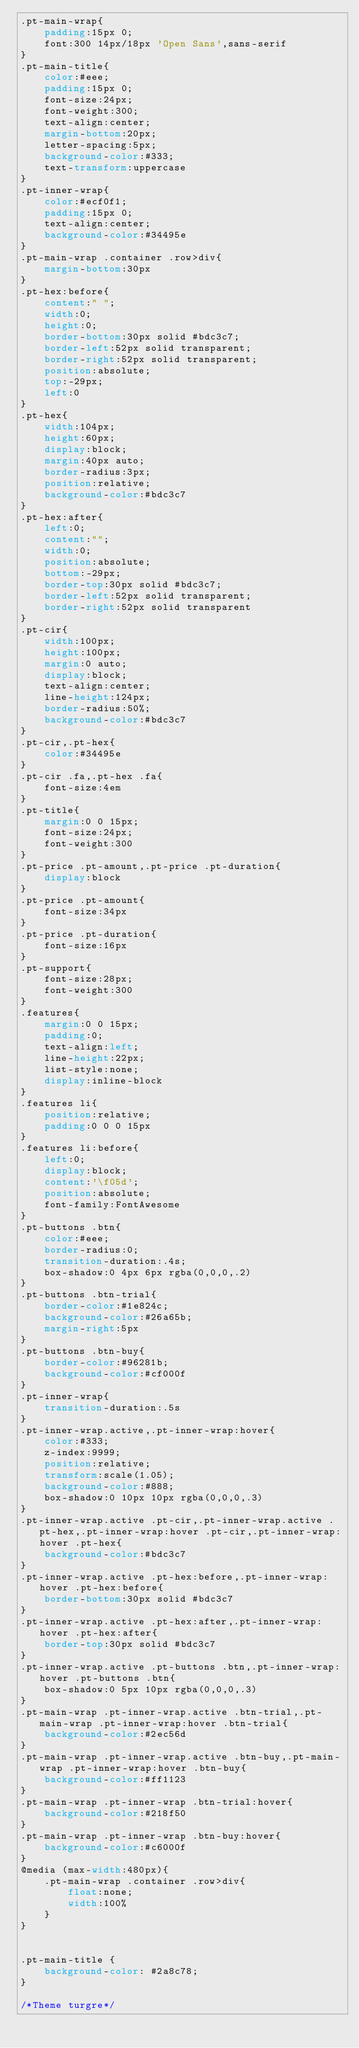<code> <loc_0><loc_0><loc_500><loc_500><_CSS_>.pt-main-wrap{
    padding:15px 0;
    font:300 14px/18px 'Open Sans',sans-serif
}
.pt-main-title{
    color:#eee;
    padding:15px 0;
    font-size:24px;
    font-weight:300;
    text-align:center;
    margin-bottom:20px;
    letter-spacing:5px;
    background-color:#333;
    text-transform:uppercase
}
.pt-inner-wrap{
    color:#ecf0f1;
    padding:15px 0;
    text-align:center;
    background-color:#34495e
}
.pt-main-wrap .container .row>div{
    margin-bottom:30px
}
.pt-hex:before{
    content:" ";
    width:0;
    height:0;
    border-bottom:30px solid #bdc3c7;
    border-left:52px solid transparent;
    border-right:52px solid transparent;
    position:absolute;
    top:-29px;
    left:0
}
.pt-hex{
    width:104px;
    height:60px;
    display:block;
    margin:40px auto;
    border-radius:3px;
    position:relative;
    background-color:#bdc3c7
}
.pt-hex:after{
    left:0;
    content:"";
    width:0;
    position:absolute;
    bottom:-29px;
    border-top:30px solid #bdc3c7;
    border-left:52px solid transparent;
    border-right:52px solid transparent
}
.pt-cir{
    width:100px;
    height:100px;
    margin:0 auto;
    display:block;
    text-align:center;
    line-height:124px;
    border-radius:50%;
    background-color:#bdc3c7
}
.pt-cir,.pt-hex{
    color:#34495e
}
.pt-cir .fa,.pt-hex .fa{
    font-size:4em
}
.pt-title{
    margin:0 0 15px;
    font-size:24px;
    font-weight:300
}
.pt-price .pt-amount,.pt-price .pt-duration{
    display:block
}
.pt-price .pt-amount{
    font-size:34px
}
.pt-price .pt-duration{
    font-size:16px
}
.pt-support{
    font-size:28px;
    font-weight:300
}
.features{
    margin:0 0 15px;
    padding:0;
    text-align:left;
    line-height:22px;
    list-style:none;
    display:inline-block
}
.features li{
    position:relative;
    padding:0 0 0 15px
}
.features li:before{
    left:0;
    display:block;
    content:'\f05d';
    position:absolute;
    font-family:FontAwesome
}
.pt-buttons .btn{
    color:#eee;
    border-radius:0;
    transition-duration:.4s;
    box-shadow:0 4px 6px rgba(0,0,0,.2)
}
.pt-buttons .btn-trial{
    border-color:#1e824c;
    background-color:#26a65b;
    margin-right:5px
}
.pt-buttons .btn-buy{
    border-color:#96281b;
    background-color:#cf000f
}
.pt-inner-wrap{
    transition-duration:.5s
}
.pt-inner-wrap.active,.pt-inner-wrap:hover{
    color:#333;
    z-index:9999;
    position:relative;
    transform:scale(1.05);
    background-color:#888;
    box-shadow:0 10px 10px rgba(0,0,0,.3)
}
.pt-inner-wrap.active .pt-cir,.pt-inner-wrap.active .pt-hex,.pt-inner-wrap:hover .pt-cir,.pt-inner-wrap:hover .pt-hex{
    background-color:#bdc3c7
}
.pt-inner-wrap.active .pt-hex:before,.pt-inner-wrap:hover .pt-hex:before{
    border-bottom:30px solid #bdc3c7
}
.pt-inner-wrap.active .pt-hex:after,.pt-inner-wrap:hover .pt-hex:after{
    border-top:30px solid #bdc3c7
}
.pt-inner-wrap.active .pt-buttons .btn,.pt-inner-wrap:hover .pt-buttons .btn{
    box-shadow:0 5px 10px rgba(0,0,0,.3)
}
.pt-main-wrap .pt-inner-wrap.active .btn-trial,.pt-main-wrap .pt-inner-wrap:hover .btn-trial{
    background-color:#2ec56d
}
.pt-main-wrap .pt-inner-wrap.active .btn-buy,.pt-main-wrap .pt-inner-wrap:hover .btn-buy{
    background-color:#ff1123
}
.pt-main-wrap .pt-inner-wrap .btn-trial:hover{
    background-color:#218f50
}
.pt-main-wrap .pt-inner-wrap .btn-buy:hover{
    background-color:#c6000f
}
@media (max-width:480px){
    .pt-main-wrap .container .row>div{
        float:none;
        width:100%
    }
}


.pt-main-title {
    background-color: #2a8c78;
}

/*Theme turgre*/</code> 